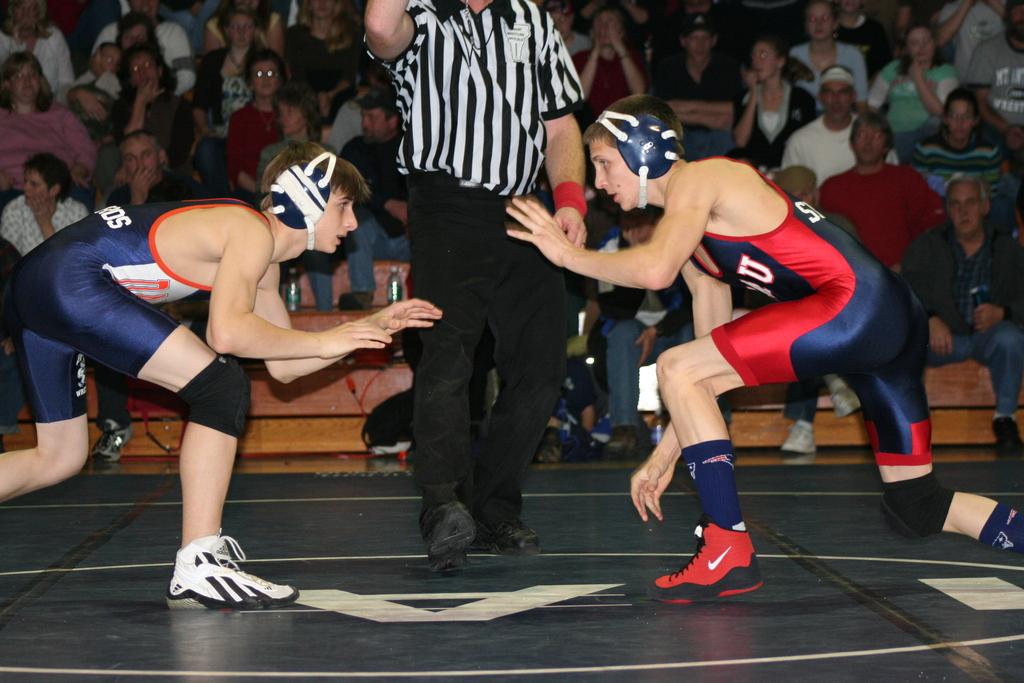What is the last letter on the back of the blue uniform?
Give a very brief answer. S. 